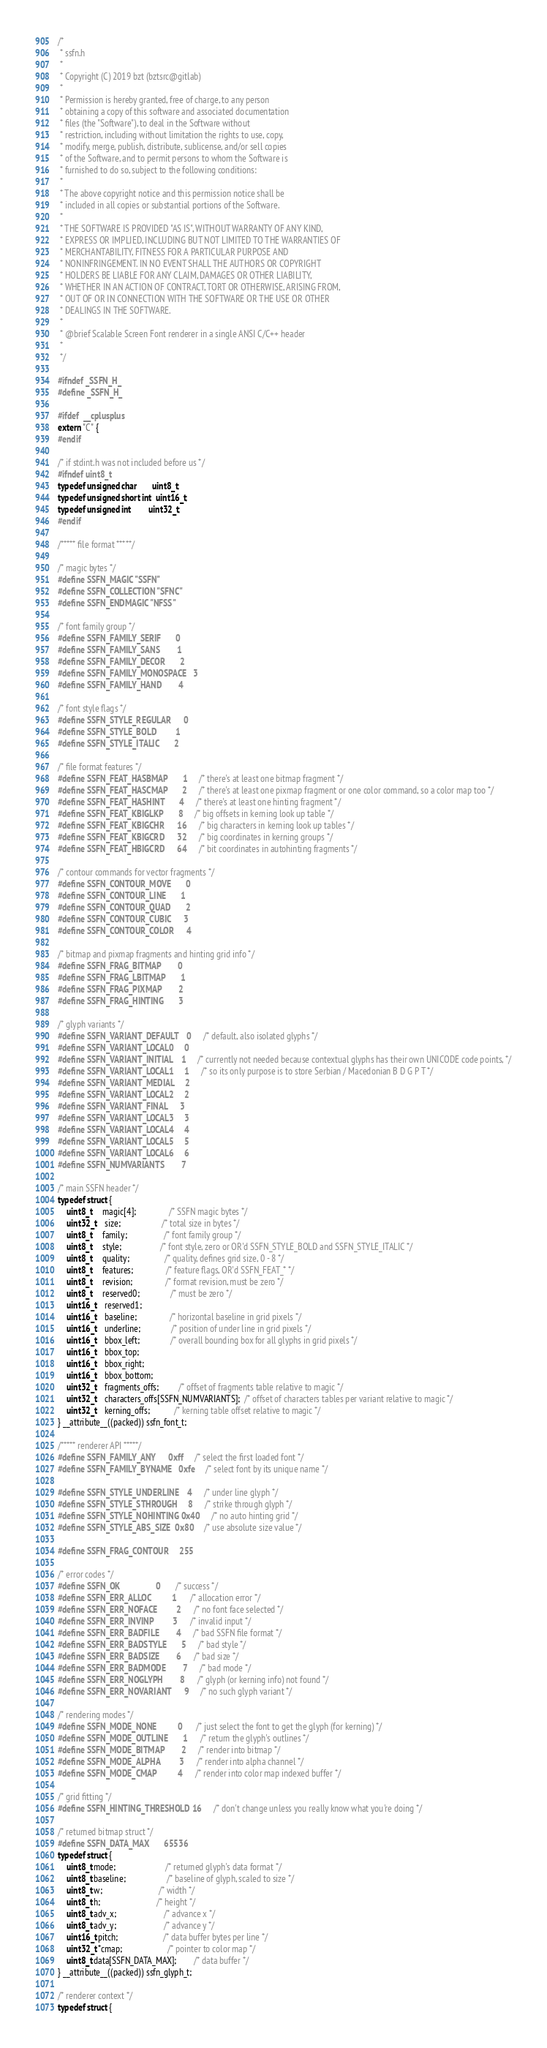Convert code to text. <code><loc_0><loc_0><loc_500><loc_500><_C_>/*
 * ssfn.h
 *
 * Copyright (C) 2019 bzt (bztsrc@gitlab)
 *
 * Permission is hereby granted, free of charge, to any person
 * obtaining a copy of this software and associated documentation
 * files (the "Software"), to deal in the Software without
 * restriction, including without limitation the rights to use, copy,
 * modify, merge, publish, distribute, sublicense, and/or sell copies
 * of the Software, and to permit persons to whom the Software is
 * furnished to do so, subject to the following conditions:
 *
 * The above copyright notice and this permission notice shall be
 * included in all copies or substantial portions of the Software.
 *
 * THE SOFTWARE IS PROVIDED "AS IS", WITHOUT WARRANTY OF ANY KIND,
 * EXPRESS OR IMPLIED, INCLUDING BUT NOT LIMITED TO THE WARRANTIES OF
 * MERCHANTABILITY, FITNESS FOR A PARTICULAR PURPOSE AND
 * NONINFRINGEMENT. IN NO EVENT SHALL THE AUTHORS OR COPYRIGHT
 * HOLDERS BE LIABLE FOR ANY CLAIM, DAMAGES OR OTHER LIABILITY,
 * WHETHER IN AN ACTION OF CONTRACT, TORT OR OTHERWISE, ARISING FROM,
 * OUT OF OR IN CONNECTION WITH THE SOFTWARE OR THE USE OR OTHER
 * DEALINGS IN THE SOFTWARE.
 *
 * @brief Scalable Screen Font renderer in a single ANSI C/C++ header
 *
 */

#ifndef _SSFN_H_
#define _SSFN_H_

#ifdef  __cplusplus
extern "C" {
#endif

/* if stdint.h was not included before us */
#ifndef uint8_t
typedef unsigned char       uint8_t;
typedef unsigned short int  uint16_t;
typedef unsigned int        uint32_t;
#endif

/***** file format *****/

/* magic bytes */
#define SSFN_MAGIC "SSFN"
#define SSFN_COLLECTION "SFNC"
#define SSFN_ENDMAGIC "NFSS"

/* font family group */
#define SSFN_FAMILY_SERIF       0
#define SSFN_FAMILY_SANS        1
#define SSFN_FAMILY_DECOR       2
#define SSFN_FAMILY_MONOSPACE   3
#define SSFN_FAMILY_HAND        4

/* font style flags */
#define SSFN_STYLE_REGULAR      0
#define SSFN_STYLE_BOLD         1
#define SSFN_STYLE_ITALIC       2

/* file format features */
#define SSFN_FEAT_HASBMAP       1       /* there's at least one bitmap fragment */
#define SSFN_FEAT_HASCMAP       2       /* there's at least one pixmap fragment or one color command, so a color map too */
#define SSFN_FEAT_HASHINT       4       /* there's at least one hinting fragment */
#define SSFN_FEAT_KBIGLKP       8       /* big offsets in kerning look up table */
#define SSFN_FEAT_KBIGCHR      16       /* big characters in kerning look up tables */
#define SSFN_FEAT_KBIGCRD      32       /* big coordinates in kerning groups */
#define SSFN_FEAT_HBIGCRD      64       /* bit coordinates in autohinting fragments */

/* contour commands for vector fragments */
#define SSFN_CONTOUR_MOVE       0
#define SSFN_CONTOUR_LINE       1
#define SSFN_CONTOUR_QUAD       2
#define SSFN_CONTOUR_CUBIC      3
#define SSFN_CONTOUR_COLOR      4

/* bitmap and pixmap fragments and hinting grid info */
#define SSFN_FRAG_BITMAP        0
#define SSFN_FRAG_LBITMAP       1
#define SSFN_FRAG_PIXMAP        2
#define SSFN_FRAG_HINTING       3

/* glyph variants */
#define SSFN_VARIANT_DEFAULT    0       /* default, also isolated glyphs */
#define SSFN_VARIANT_LOCAL0     0
#define SSFN_VARIANT_INITIAL    1       /* currently not needed because contextual glyphs has their own UNICODE code points, */
#define SSFN_VARIANT_LOCAL1     1       /* so its only purpose is to store Serbian / Macedonian B D G P T */
#define SSFN_VARIANT_MEDIAL     2
#define SSFN_VARIANT_LOCAL2     2
#define SSFN_VARIANT_FINAL      3
#define SSFN_VARIANT_LOCAL3     3
#define SSFN_VARIANT_LOCAL4     4
#define SSFN_VARIANT_LOCAL5     5
#define SSFN_VARIANT_LOCAL6     6
#define SSFN_NUMVARIANTS        7

/* main SSFN header */
typedef struct {
    uint8_t     magic[4];               /* SSFN magic bytes */
    uint32_t    size;                   /* total size in bytes */
    uint8_t     family;                 /* font family group */
    uint8_t     style;                  /* font style, zero or OR'd SSFN_STYLE_BOLD and SSFN_STYLE_ITALIC */
    uint8_t     quality;                /* quality, defines grid size, 0 - 8 */
    uint8_t     features;               /* feature flags, OR'd SSFN_FEAT_* */
    uint8_t     revision;               /* format revision, must be zero */
    uint8_t     reserved0;              /* must be zero */
    uint16_t    reserved1;
    uint16_t    baseline;               /* horizontal baseline in grid pixels */
    uint16_t    underline;              /* position of under line in grid pixels */
    uint16_t    bbox_left;              /* overall bounding box for all glyphs in grid pixels */
    uint16_t    bbox_top;
    uint16_t    bbox_right;
    uint16_t    bbox_bottom;
    uint32_t    fragments_offs;         /* offset of fragments table relative to magic */
    uint32_t    characters_offs[SSFN_NUMVARIANTS];  /* offset of characters tables per variant relative to magic */
    uint32_t    kerning_offs;           /* kerning table offset relative to magic */
} __attribute__((packed)) ssfn_font_t;

/***** renderer API *****/
#define SSFN_FAMILY_ANY      0xff       /* select the first loaded font */
#define SSFN_FAMILY_BYNAME   0xfe       /* select font by its unique name */

#define SSFN_STYLE_UNDERLINE    4       /* under line glyph */
#define SSFN_STYLE_STHROUGH     8       /* strike through glyph */
#define SSFN_STYLE_NOHINTING 0x40       /* no auto hinting grid */
#define SSFN_STYLE_ABS_SIZE  0x80       /* use absolute size value */

#define SSFN_FRAG_CONTOUR     255

/* error codes */
#define SSFN_OK                 0       /* success */
#define SSFN_ERR_ALLOC          1       /* allocation error */
#define SSFN_ERR_NOFACE         2       /* no font face selected */
#define SSFN_ERR_INVINP         3       /* invalid input */
#define SSFN_ERR_BADFILE        4       /* bad SSFN file format */
#define SSFN_ERR_BADSTYLE       5       /* bad style */
#define SSFN_ERR_BADSIZE        6       /* bad size */
#define SSFN_ERR_BADMODE        7       /* bad mode */
#define SSFN_ERR_NOGLYPH        8       /* glyph (or kerning info) not found */
#define SSFN_ERR_NOVARIANT      9       /* no such glyph variant */

/* rendering modes */
#define SSFN_MODE_NONE          0       /* just select the font to get the glyph (for kerning) */
#define SSFN_MODE_OUTLINE       1       /* return the glyph's outlines */
#define SSFN_MODE_BITMAP        2       /* render into bitmap */
#define SSFN_MODE_ALPHA         3       /* render into alpha channel */
#define SSFN_MODE_CMAP          4       /* render into color map indexed buffer */

/* grid fitting */
#define SSFN_HINTING_THRESHOLD 16       /* don't change unless you really know what you're doing */

/* returned bitmap struct */
#define SSFN_DATA_MAX       65536
typedef struct {
    uint8_t mode;                       /* returned glyph's data format */
    uint8_t baseline;                   /* baseline of glyph, scaled to size */
    uint8_t w;                          /* width */
    uint8_t h;                          /* height */
    uint8_t adv_x;                      /* advance x */
    uint8_t adv_y;                      /* advance y */
    uint16_t pitch;                     /* data buffer bytes per line */
    uint32_t *cmap;                     /* pointer to color map */
    uint8_t data[SSFN_DATA_MAX];        /* data buffer */
} __attribute__((packed)) ssfn_glyph_t;

/* renderer context */
typedef struct {</code> 